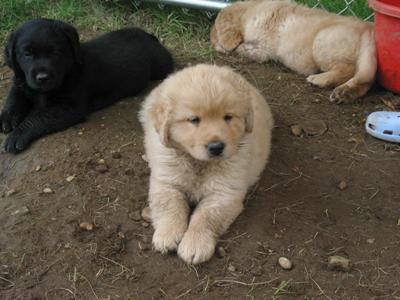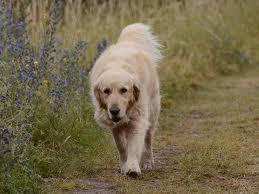The first image is the image on the left, the second image is the image on the right. For the images displayed, is the sentence "One of the images shows exactly three puppies." factually correct? Answer yes or no. Yes. The first image is the image on the left, the second image is the image on the right. Given the left and right images, does the statement "An image shows two beige pups and one black pup." hold true? Answer yes or no. Yes. 